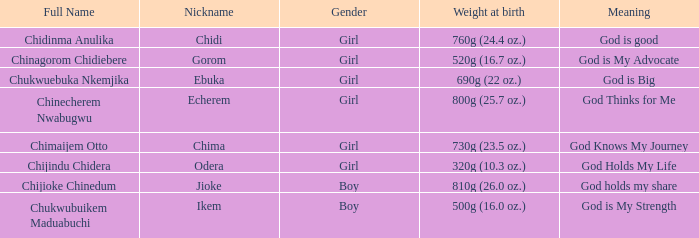How much did the girl, nicknamed Chidi, weigh at birth? 760g (24.4 oz.). 